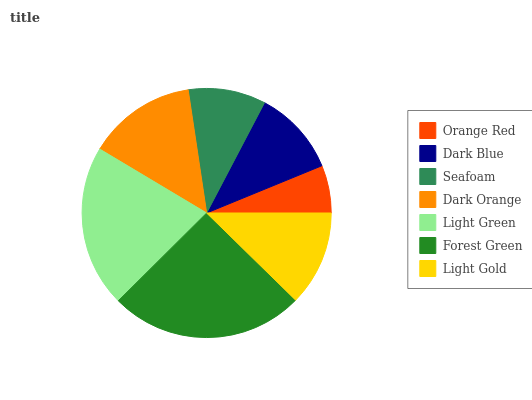Is Orange Red the minimum?
Answer yes or no. Yes. Is Forest Green the maximum?
Answer yes or no. Yes. Is Dark Blue the minimum?
Answer yes or no. No. Is Dark Blue the maximum?
Answer yes or no. No. Is Dark Blue greater than Orange Red?
Answer yes or no. Yes. Is Orange Red less than Dark Blue?
Answer yes or no. Yes. Is Orange Red greater than Dark Blue?
Answer yes or no. No. Is Dark Blue less than Orange Red?
Answer yes or no. No. Is Light Gold the high median?
Answer yes or no. Yes. Is Light Gold the low median?
Answer yes or no. Yes. Is Orange Red the high median?
Answer yes or no. No. Is Light Green the low median?
Answer yes or no. No. 